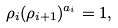<formula> <loc_0><loc_0><loc_500><loc_500>\rho _ { i } ( \rho _ { i + 1 } ) ^ { a _ { i } } = 1 ,</formula> 